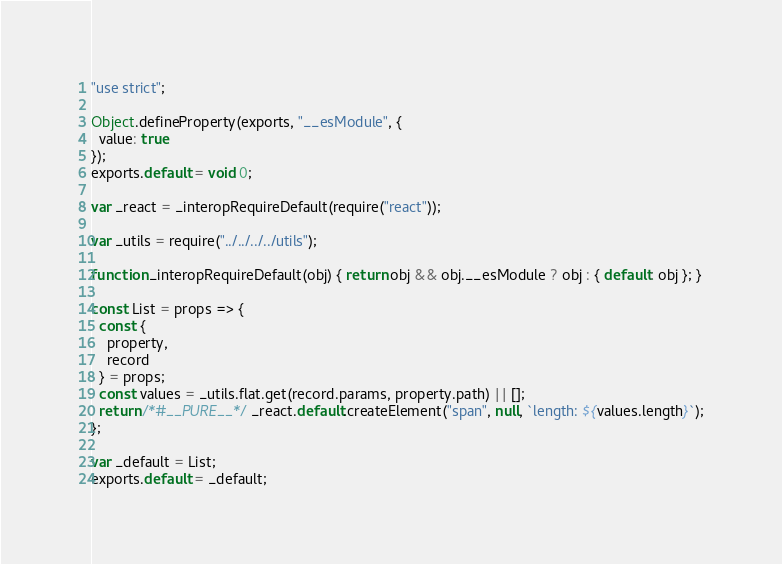<code> <loc_0><loc_0><loc_500><loc_500><_JavaScript_>"use strict";

Object.defineProperty(exports, "__esModule", {
  value: true
});
exports.default = void 0;

var _react = _interopRequireDefault(require("react"));

var _utils = require("../../../../utils");

function _interopRequireDefault(obj) { return obj && obj.__esModule ? obj : { default: obj }; }

const List = props => {
  const {
    property,
    record
  } = props;
  const values = _utils.flat.get(record.params, property.path) || [];
  return /*#__PURE__*/_react.default.createElement("span", null, `length: ${values.length}`);
};

var _default = List;
exports.default = _default;</code> 